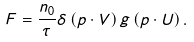<formula> <loc_0><loc_0><loc_500><loc_500>F = \frac { n _ { 0 } } { \tau } \delta \left ( p \cdot V \right ) g \left ( p \cdot U \right ) .</formula> 